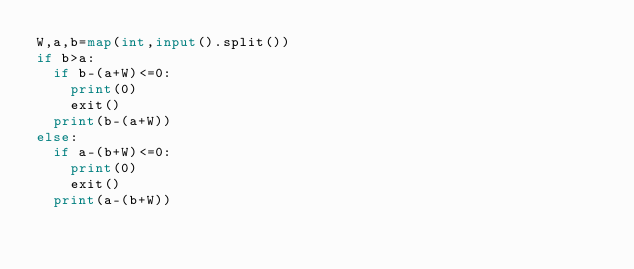<code> <loc_0><loc_0><loc_500><loc_500><_Python_>W,a,b=map(int,input().split())
if b>a:
  if b-(a+W)<=0:
  	print(0)
  	exit()
  print(b-(a+W))
else:
  if a-(b+W)<=0:
  	print(0)
  	exit()
  print(a-(b+W))</code> 